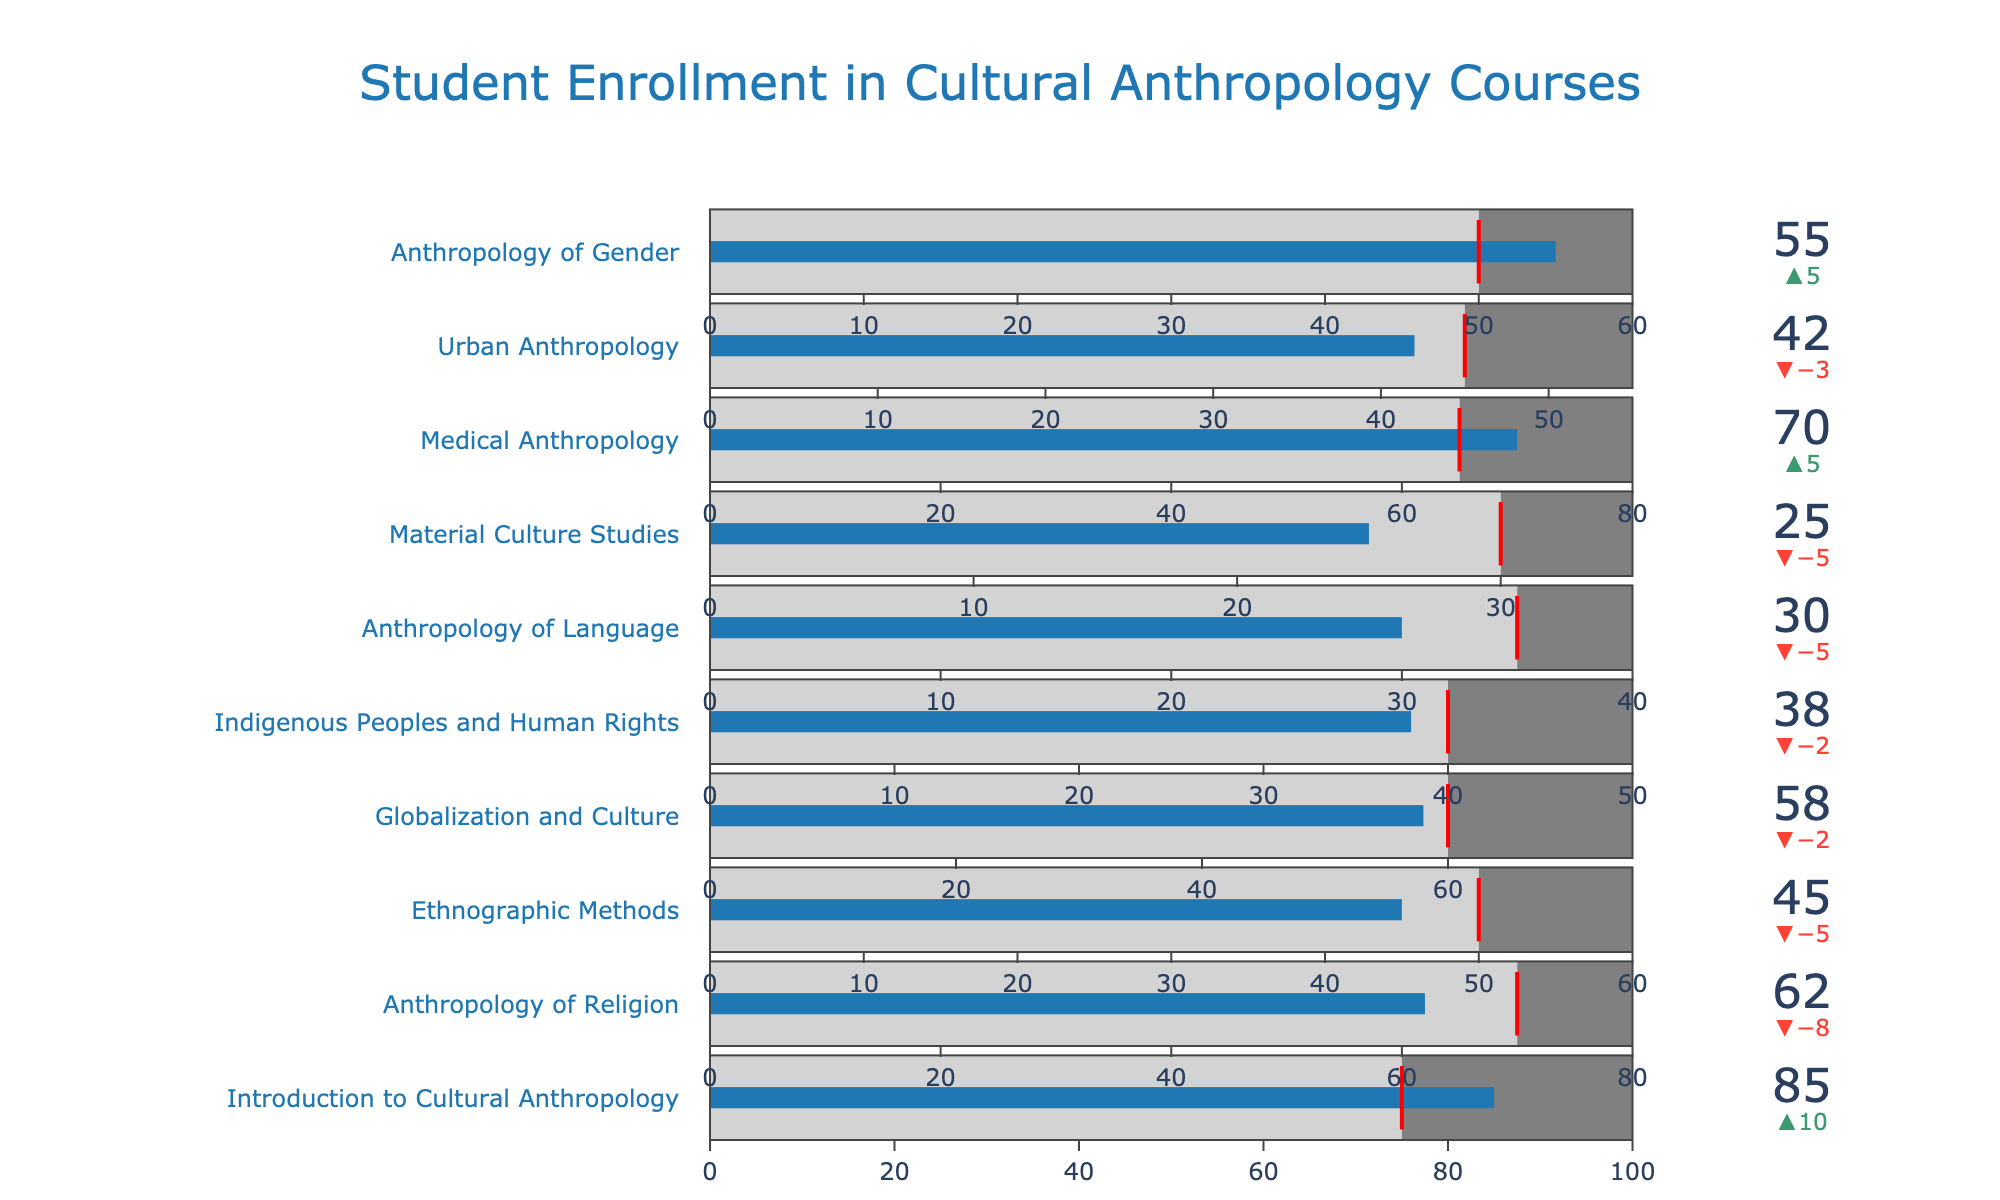How many courses exceeded their target enrollment? To find this, look at each course's actual enrollment and compare it to the target enrollment. Courses with actual enrollment greater than the target are counted. Introduction to Cultural Anthropology, Medical Anthropology, Anthropology of Gender
Answer: 3 Which course had the highest actual enrollment? Compare the actual enrollment values for all courses. The highest value is 85 for Introduction to Cultural Anthropology.
Answer: Introduction to Cultural Anthropology What is the difference between the actual and target enrollments for Medical Anthropology? Subtract the target enrollment from the actual enrollment. For Medical Anthropology, it is 70 - 65 = 5.
Answer: 5 Which course is closest to reaching its maximum capacity? Assess the difference between the actual enrollment and the maximum capacity for each course. The smallest difference is for Medical Anthropology, with a difference of 10 (80 - 70).
Answer: Medical Anthropology Which course has the smallest enrollment compared to its target? Calculate the difference between the target and actual enrollments for each course. The largest difference is for Anthropology of Language with 35 - 30 = 5.
Answer: Anthropology of Language How many courses have actual enrollment below the target? Count the courses where the actual enrollment is less than the target. Anthropology of Religion, Ethnographic Methods, Globalization and Culture, Indigenous Peoples and Human Rights, Anthropology of Language, Material Culture Studies, and Urban Anthropology
Answer: 7 What is the total actual enrollment for all the courses? Sum up all the actual enrollment numbers. 85 + 62 + 45 + 58 + 38 + 30 + 25 + 70 + 42 + 55 = 510.
Answer: 510 How many courses have at least 50 students enrolled? Count the courses with actual enrollment of 50 or more. Introduction to Cultural Anthropology, Anthropology of Religion, Globalization and Culture, Medical Anthropology, Anthropology of Gender
Answer: 5 Which course has the greatest positive difference between actual and target enrollments? Identify the courses where the actual enrollment exceeds the target and calculate the difference for each. The greatest difference is for Introduction to Cultural Anthropology with 85 - 75 = 10.
Answer: Introduction to Cultural Anthropology 